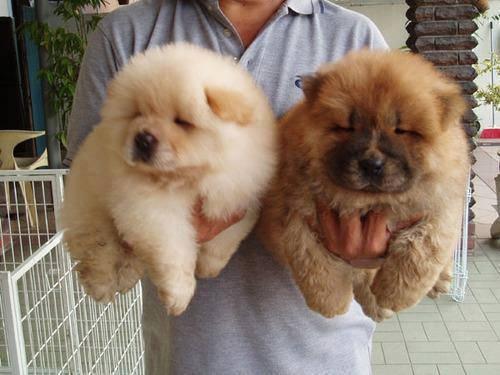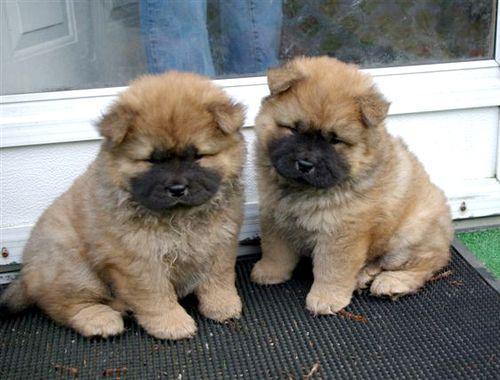The first image is the image on the left, the second image is the image on the right. For the images shown, is this caption "There is a person holding exactly one dog in the image on the left" true? Answer yes or no. No. The first image is the image on the left, the second image is the image on the right. Examine the images to the left and right. Is the description "All images show only very young chow pups, and each image shows the same number." accurate? Answer yes or no. Yes. 